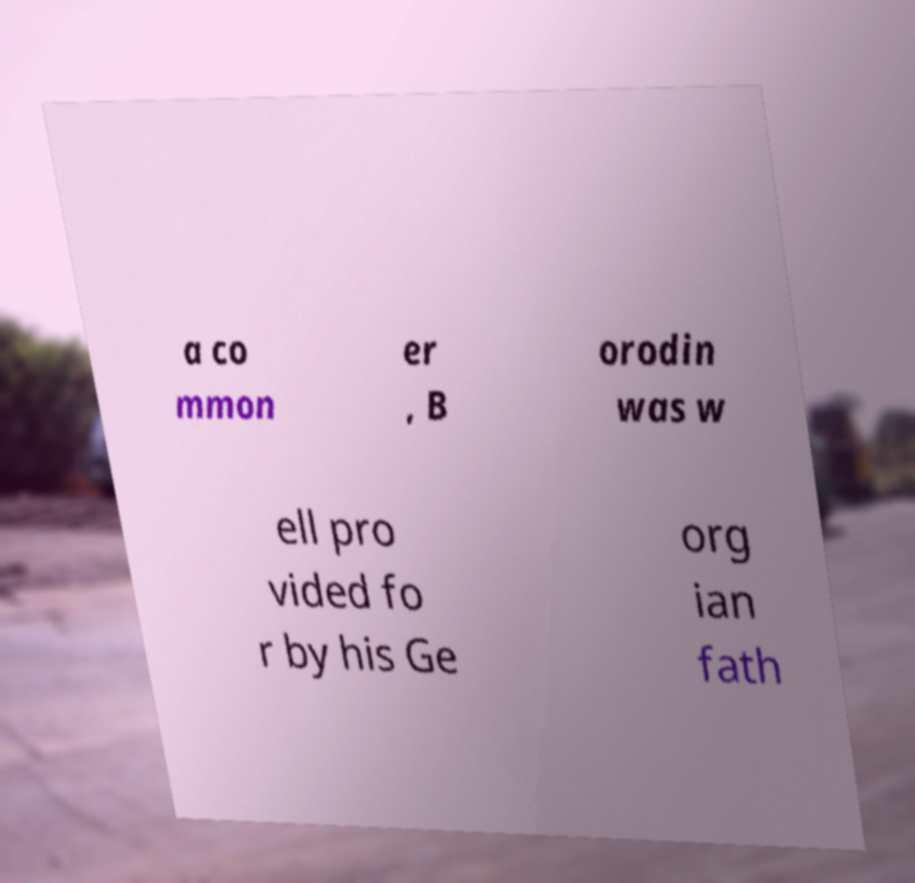Can you accurately transcribe the text from the provided image for me? a co mmon er , B orodin was w ell pro vided fo r by his Ge org ian fath 